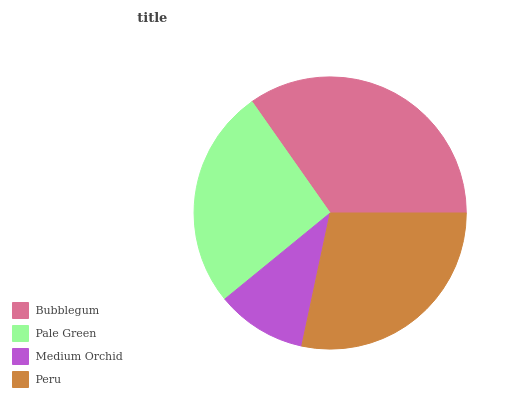Is Medium Orchid the minimum?
Answer yes or no. Yes. Is Bubblegum the maximum?
Answer yes or no. Yes. Is Pale Green the minimum?
Answer yes or no. No. Is Pale Green the maximum?
Answer yes or no. No. Is Bubblegum greater than Pale Green?
Answer yes or no. Yes. Is Pale Green less than Bubblegum?
Answer yes or no. Yes. Is Pale Green greater than Bubblegum?
Answer yes or no. No. Is Bubblegum less than Pale Green?
Answer yes or no. No. Is Peru the high median?
Answer yes or no. Yes. Is Pale Green the low median?
Answer yes or no. Yes. Is Bubblegum the high median?
Answer yes or no. No. Is Peru the low median?
Answer yes or no. No. 